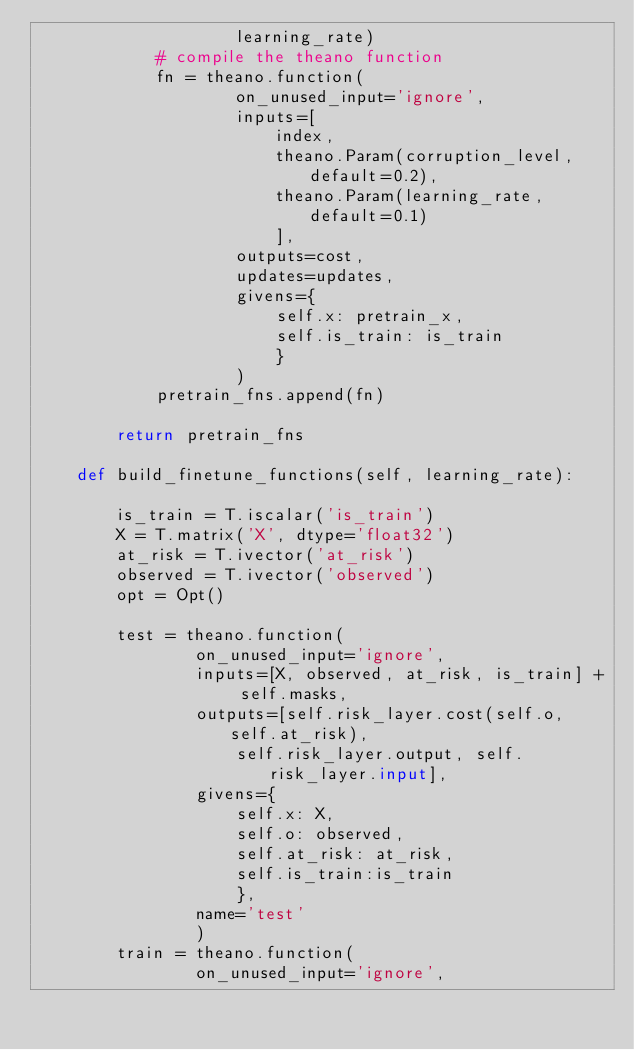Convert code to text. <code><loc_0><loc_0><loc_500><loc_500><_Python_>					learning_rate)
			# compile the theano function
			fn = theano.function(
					on_unused_input='ignore',
					inputs=[
						index,
						theano.Param(corruption_level, default=0.2),
						theano.Param(learning_rate, default=0.1)
						],
					outputs=cost,
					updates=updates,
					givens={
						self.x: pretrain_x,
						self.is_train: is_train
						}
					)
			pretrain_fns.append(fn)

		return pretrain_fns

	def build_finetune_functions(self, learning_rate):

		is_train = T.iscalar('is_train')
		X = T.matrix('X', dtype='float32')
		at_risk = T.ivector('at_risk')
		observed = T.ivector('observed')
		opt = Opt()

		test = theano.function(
				on_unused_input='ignore',
				inputs=[X, observed, at_risk, is_train] + self.masks,
				outputs=[self.risk_layer.cost(self.o, self.at_risk),
					self.risk_layer.output, self.risk_layer.input],
				givens={
					self.x: X,
					self.o: observed,
					self.at_risk: at_risk,
					self.is_train:is_train
					},
				name='test'
				)
		train = theano.function(
				on_unused_input='ignore',</code> 